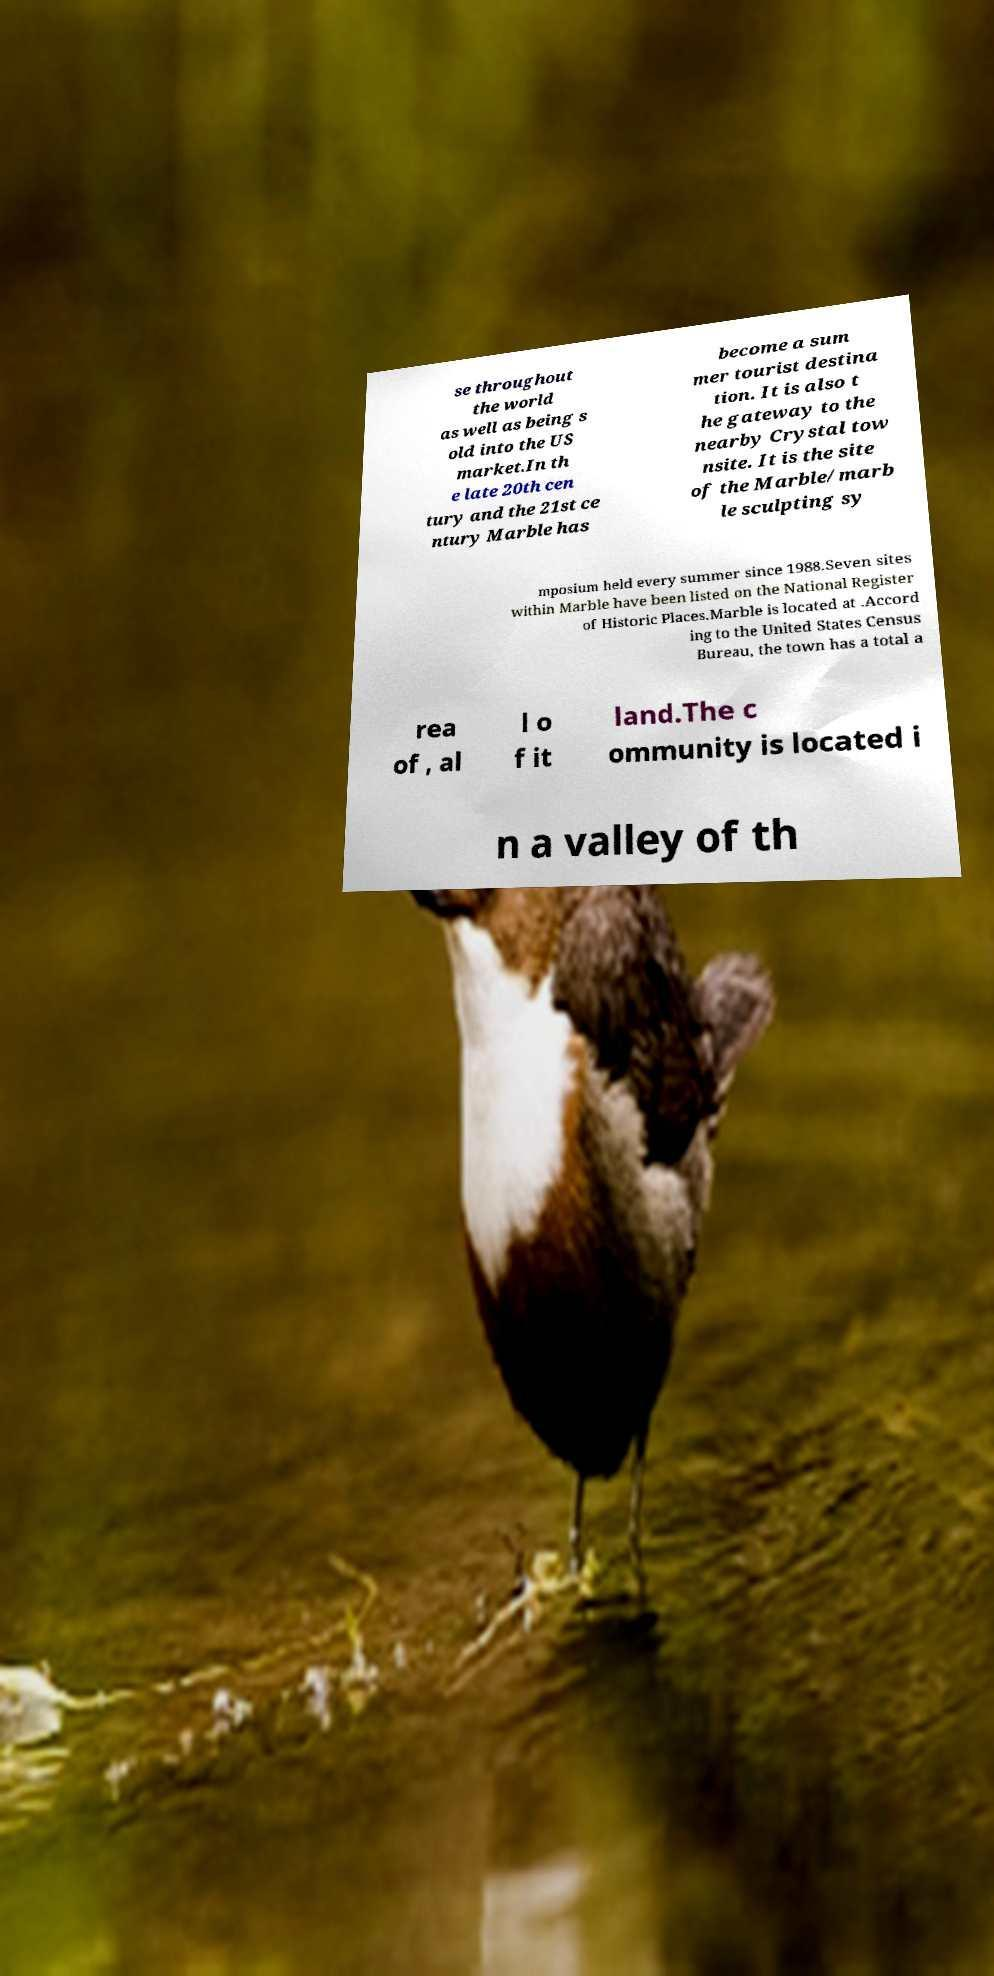There's text embedded in this image that I need extracted. Can you transcribe it verbatim? se throughout the world as well as being s old into the US market.In th e late 20th cen tury and the 21st ce ntury Marble has become a sum mer tourist destina tion. It is also t he gateway to the nearby Crystal tow nsite. It is the site of the Marble/marb le sculpting sy mposium held every summer since 1988.Seven sites within Marble have been listed on the National Register of Historic Places.Marble is located at .Accord ing to the United States Census Bureau, the town has a total a rea of , al l o f it land.The c ommunity is located i n a valley of th 